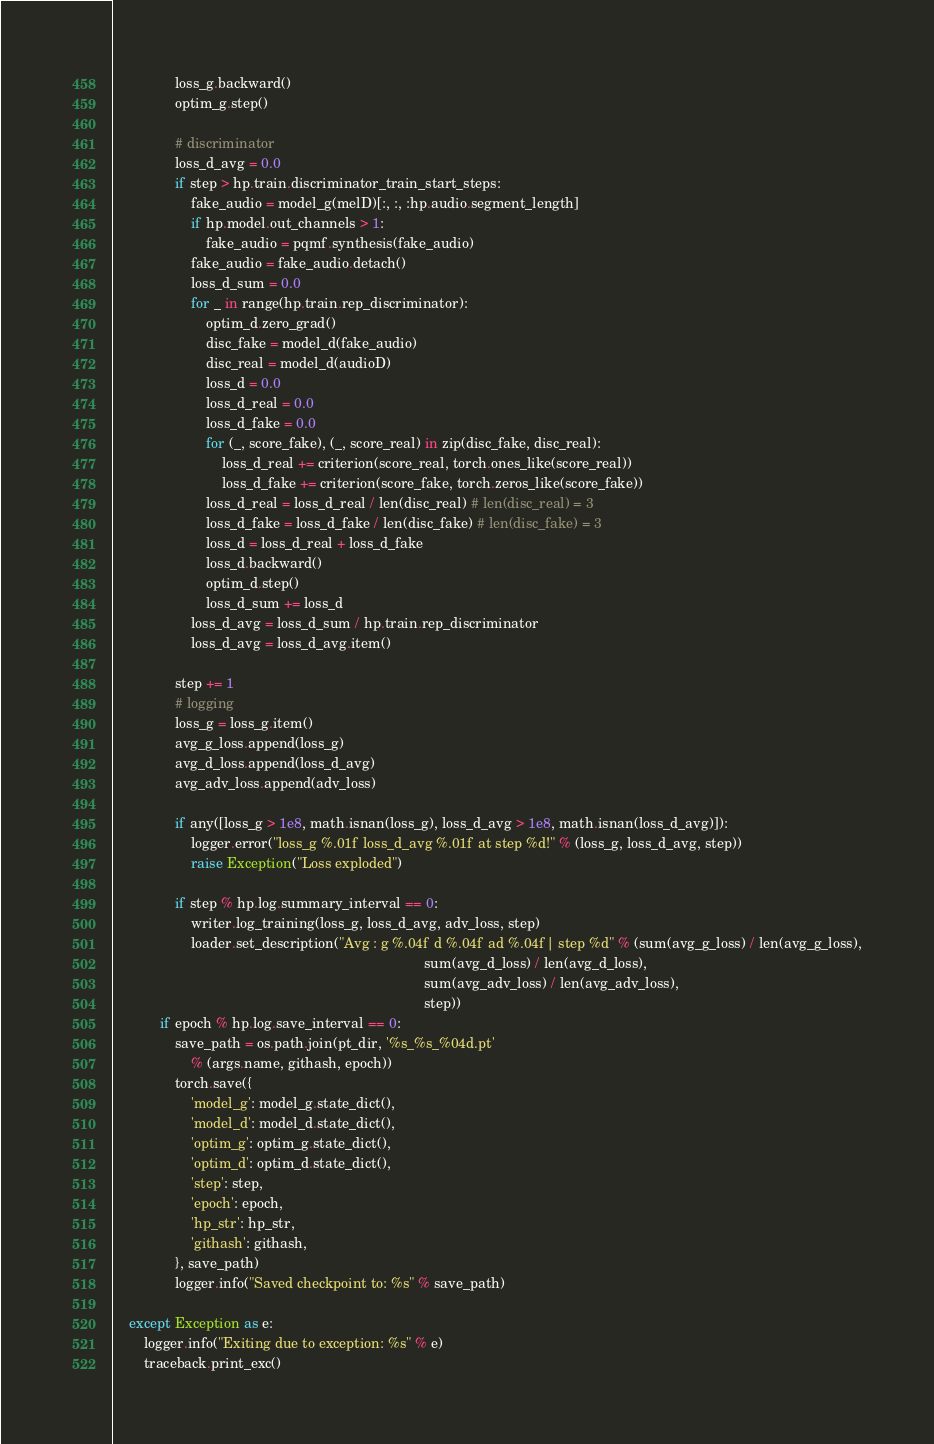Convert code to text. <code><loc_0><loc_0><loc_500><loc_500><_Python_>                loss_g.backward()
                optim_g.step()

                # discriminator
                loss_d_avg = 0.0
                if step > hp.train.discriminator_train_start_steps:
                    fake_audio = model_g(melD)[:, :, :hp.audio.segment_length]
                    if hp.model.out_channels > 1:
                        fake_audio = pqmf.synthesis(fake_audio)
                    fake_audio = fake_audio.detach()
                    loss_d_sum = 0.0
                    for _ in range(hp.train.rep_discriminator):
                        optim_d.zero_grad()
                        disc_fake = model_d(fake_audio)
                        disc_real = model_d(audioD)
                        loss_d = 0.0
                        loss_d_real = 0.0
                        loss_d_fake = 0.0
                        for (_, score_fake), (_, score_real) in zip(disc_fake, disc_real):
                            loss_d_real += criterion(score_real, torch.ones_like(score_real))
                            loss_d_fake += criterion(score_fake, torch.zeros_like(score_fake))
                        loss_d_real = loss_d_real / len(disc_real) # len(disc_real) = 3
                        loss_d_fake = loss_d_fake / len(disc_fake) # len(disc_fake) = 3
                        loss_d = loss_d_real + loss_d_fake
                        loss_d.backward()
                        optim_d.step()
                        loss_d_sum += loss_d
                    loss_d_avg = loss_d_sum / hp.train.rep_discriminator
                    loss_d_avg = loss_d_avg.item()

                step += 1
                # logging
                loss_g = loss_g.item()
                avg_g_loss.append(loss_g)
                avg_d_loss.append(loss_d_avg)
                avg_adv_loss.append(adv_loss)

                if any([loss_g > 1e8, math.isnan(loss_g), loss_d_avg > 1e8, math.isnan(loss_d_avg)]):
                    logger.error("loss_g %.01f loss_d_avg %.01f at step %d!" % (loss_g, loss_d_avg, step))
                    raise Exception("Loss exploded")

                if step % hp.log.summary_interval == 0:
                    writer.log_training(loss_g, loss_d_avg, adv_loss, step)
                    loader.set_description("Avg : g %.04f d %.04f ad %.04f| step %d" % (sum(avg_g_loss) / len(avg_g_loss),
                                                                                sum(avg_d_loss) / len(avg_d_loss),
                                                                                sum(avg_adv_loss) / len(avg_adv_loss),
                                                                                step))
            if epoch % hp.log.save_interval == 0:
                save_path = os.path.join(pt_dir, '%s_%s_%04d.pt'
                    % (args.name, githash, epoch))
                torch.save({
                    'model_g': model_g.state_dict(),
                    'model_d': model_d.state_dict(),
                    'optim_g': optim_g.state_dict(),
                    'optim_d': optim_d.state_dict(),
                    'step': step,
                    'epoch': epoch,
                    'hp_str': hp_str,
                    'githash': githash,
                }, save_path)
                logger.info("Saved checkpoint to: %s" % save_path)

    except Exception as e:
        logger.info("Exiting due to exception: %s" % e)
        traceback.print_exc()
</code> 